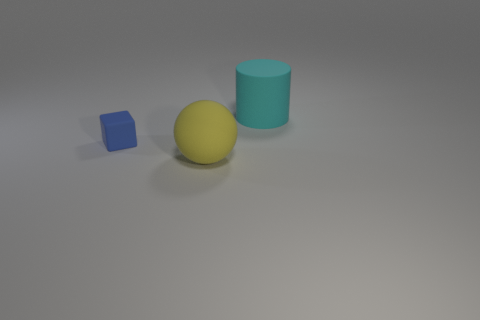Add 2 yellow things. How many objects exist? 5 Subtract all cubes. How many objects are left? 2 Subtract 0 gray blocks. How many objects are left? 3 Subtract all small red metallic objects. Subtract all rubber balls. How many objects are left? 2 Add 2 large yellow matte things. How many large yellow matte things are left? 3 Add 2 cyan rubber things. How many cyan rubber things exist? 3 